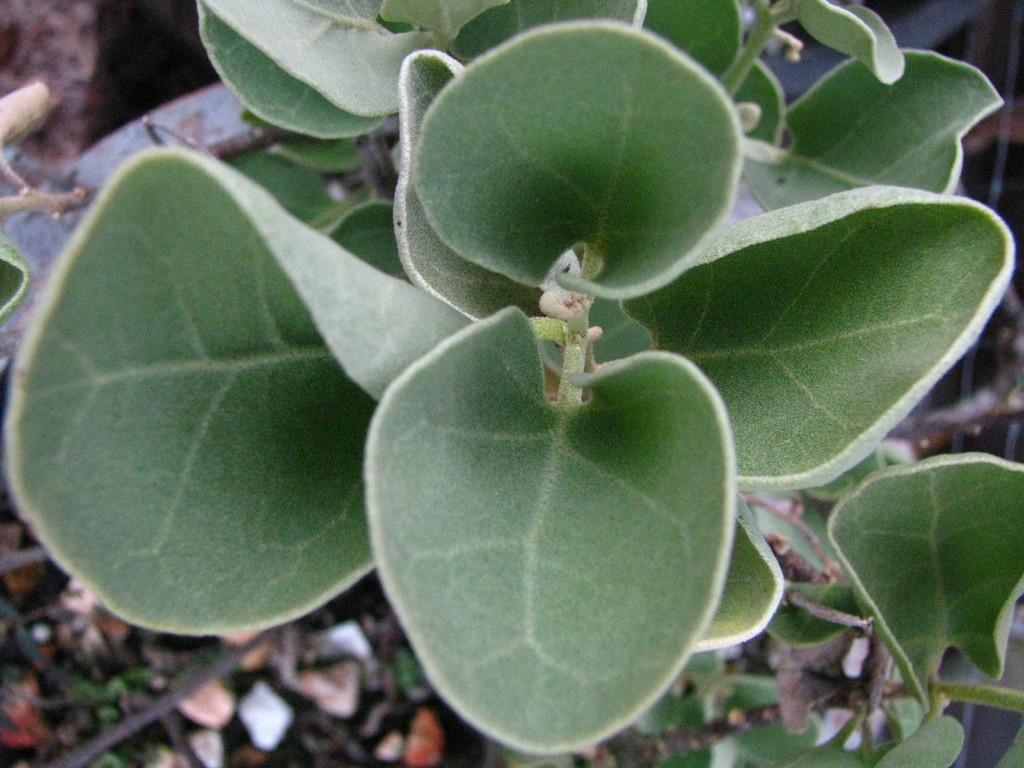What type of plant material is visible in the image? The image contains leaves of a plant. What other plant materials can be seen at the bottom of the image? There are dry sticks and dry leaves present at the bottom of the image. What type of hospital can be seen in the background of the image? There is no hospital present in the image; it only contains plant materials. 